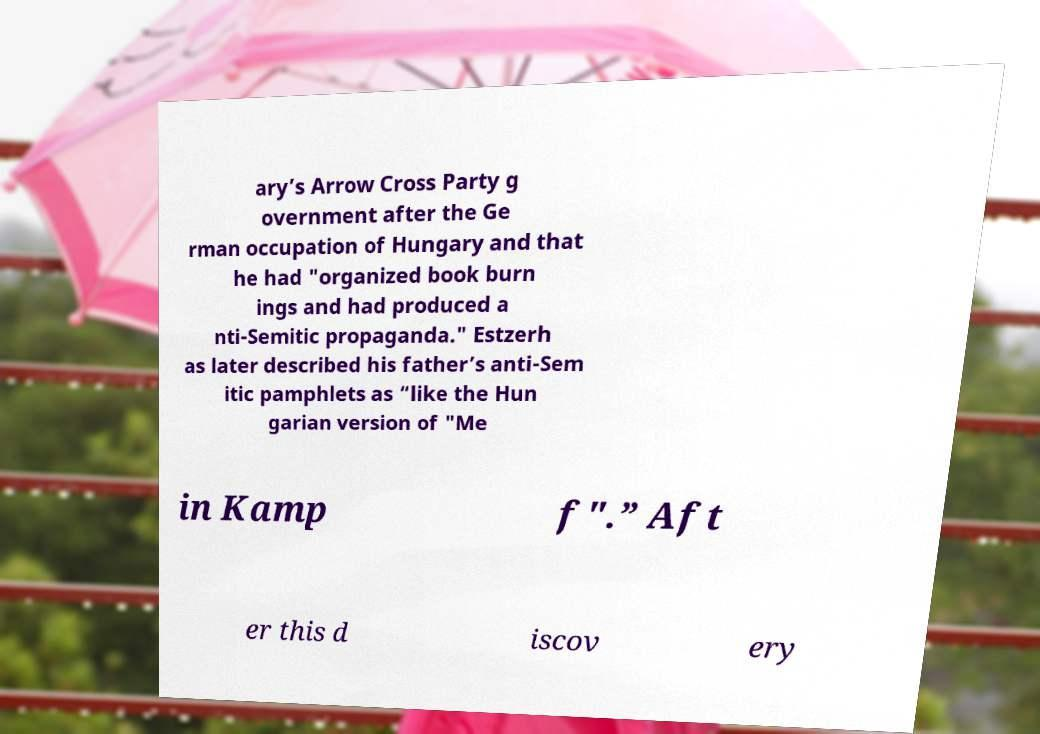Please identify and transcribe the text found in this image. ary’s Arrow Cross Party g overnment after the Ge rman occupation of Hungary and that he had "organized book burn ings and had produced a nti-Semitic propaganda." Estzerh as later described his father’s anti-Sem itic pamphlets as “like the Hun garian version of "Me in Kamp f".” Aft er this d iscov ery 